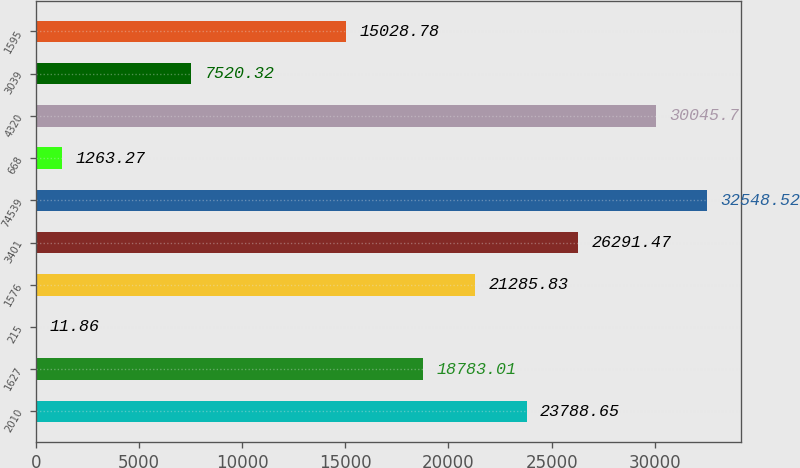<chart> <loc_0><loc_0><loc_500><loc_500><bar_chart><fcel>2010<fcel>1627<fcel>215<fcel>1576<fcel>3401<fcel>74539<fcel>668<fcel>4320<fcel>3039<fcel>1595<nl><fcel>23788.7<fcel>18783<fcel>11.86<fcel>21285.8<fcel>26291.5<fcel>32548.5<fcel>1263.27<fcel>30045.7<fcel>7520.32<fcel>15028.8<nl></chart> 